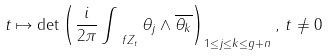<formula> <loc_0><loc_0><loc_500><loc_500>t \mapsto \det \left ( \frac { i } { 2 \pi } \int _ { \ f Z _ { t } } \theta _ { j } \wedge \overline { \theta _ { k } } \right ) _ { 1 \leq j \leq k \leq g + n } , \, t \neq 0</formula> 